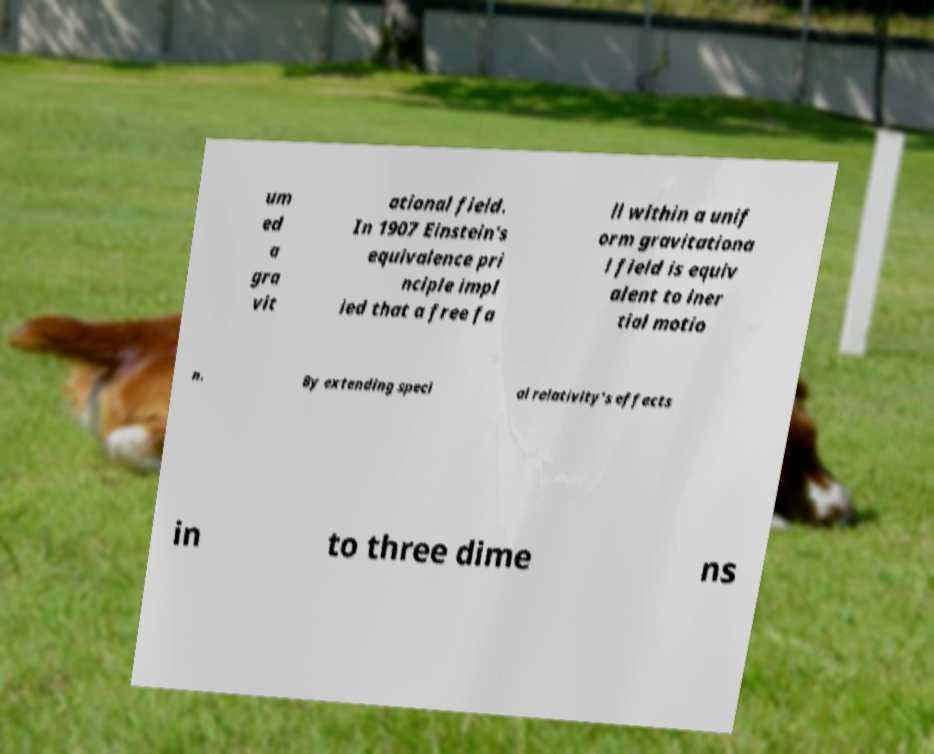I need the written content from this picture converted into text. Can you do that? um ed a gra vit ational field. In 1907 Einstein's equivalence pri nciple impl ied that a free fa ll within a unif orm gravitationa l field is equiv alent to iner tial motio n. By extending speci al relativity's effects in to three dime ns 